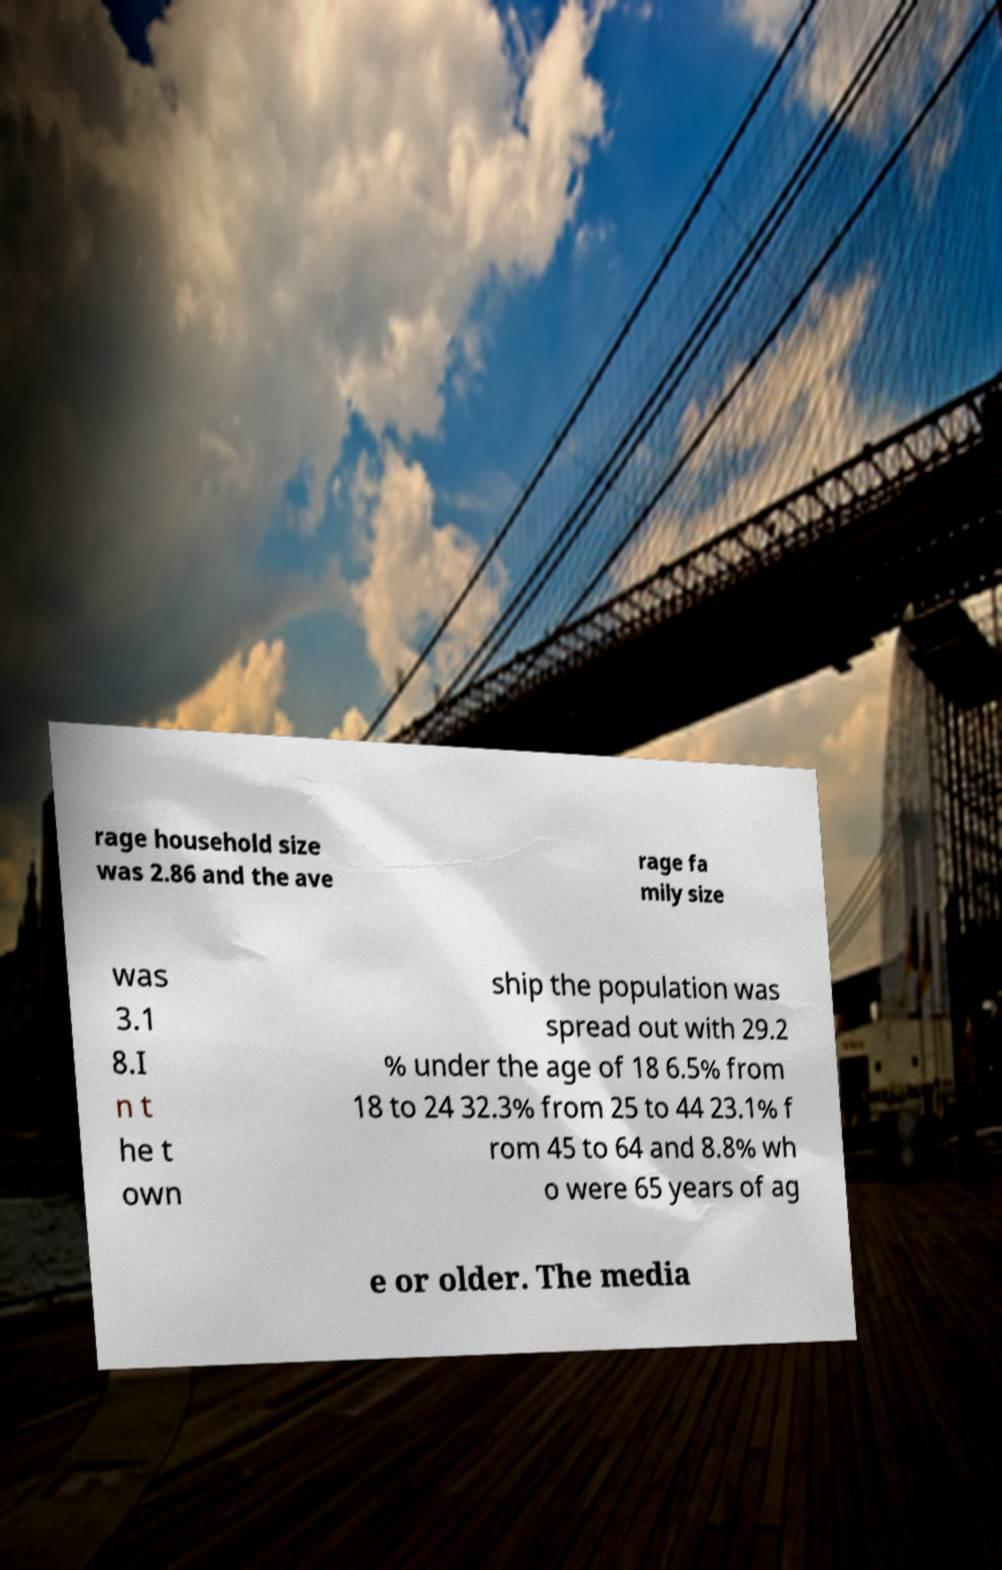Can you read and provide the text displayed in the image?This photo seems to have some interesting text. Can you extract and type it out for me? rage household size was 2.86 and the ave rage fa mily size was 3.1 8.I n t he t own ship the population was spread out with 29.2 % under the age of 18 6.5% from 18 to 24 32.3% from 25 to 44 23.1% f rom 45 to 64 and 8.8% wh o were 65 years of ag e or older. The media 